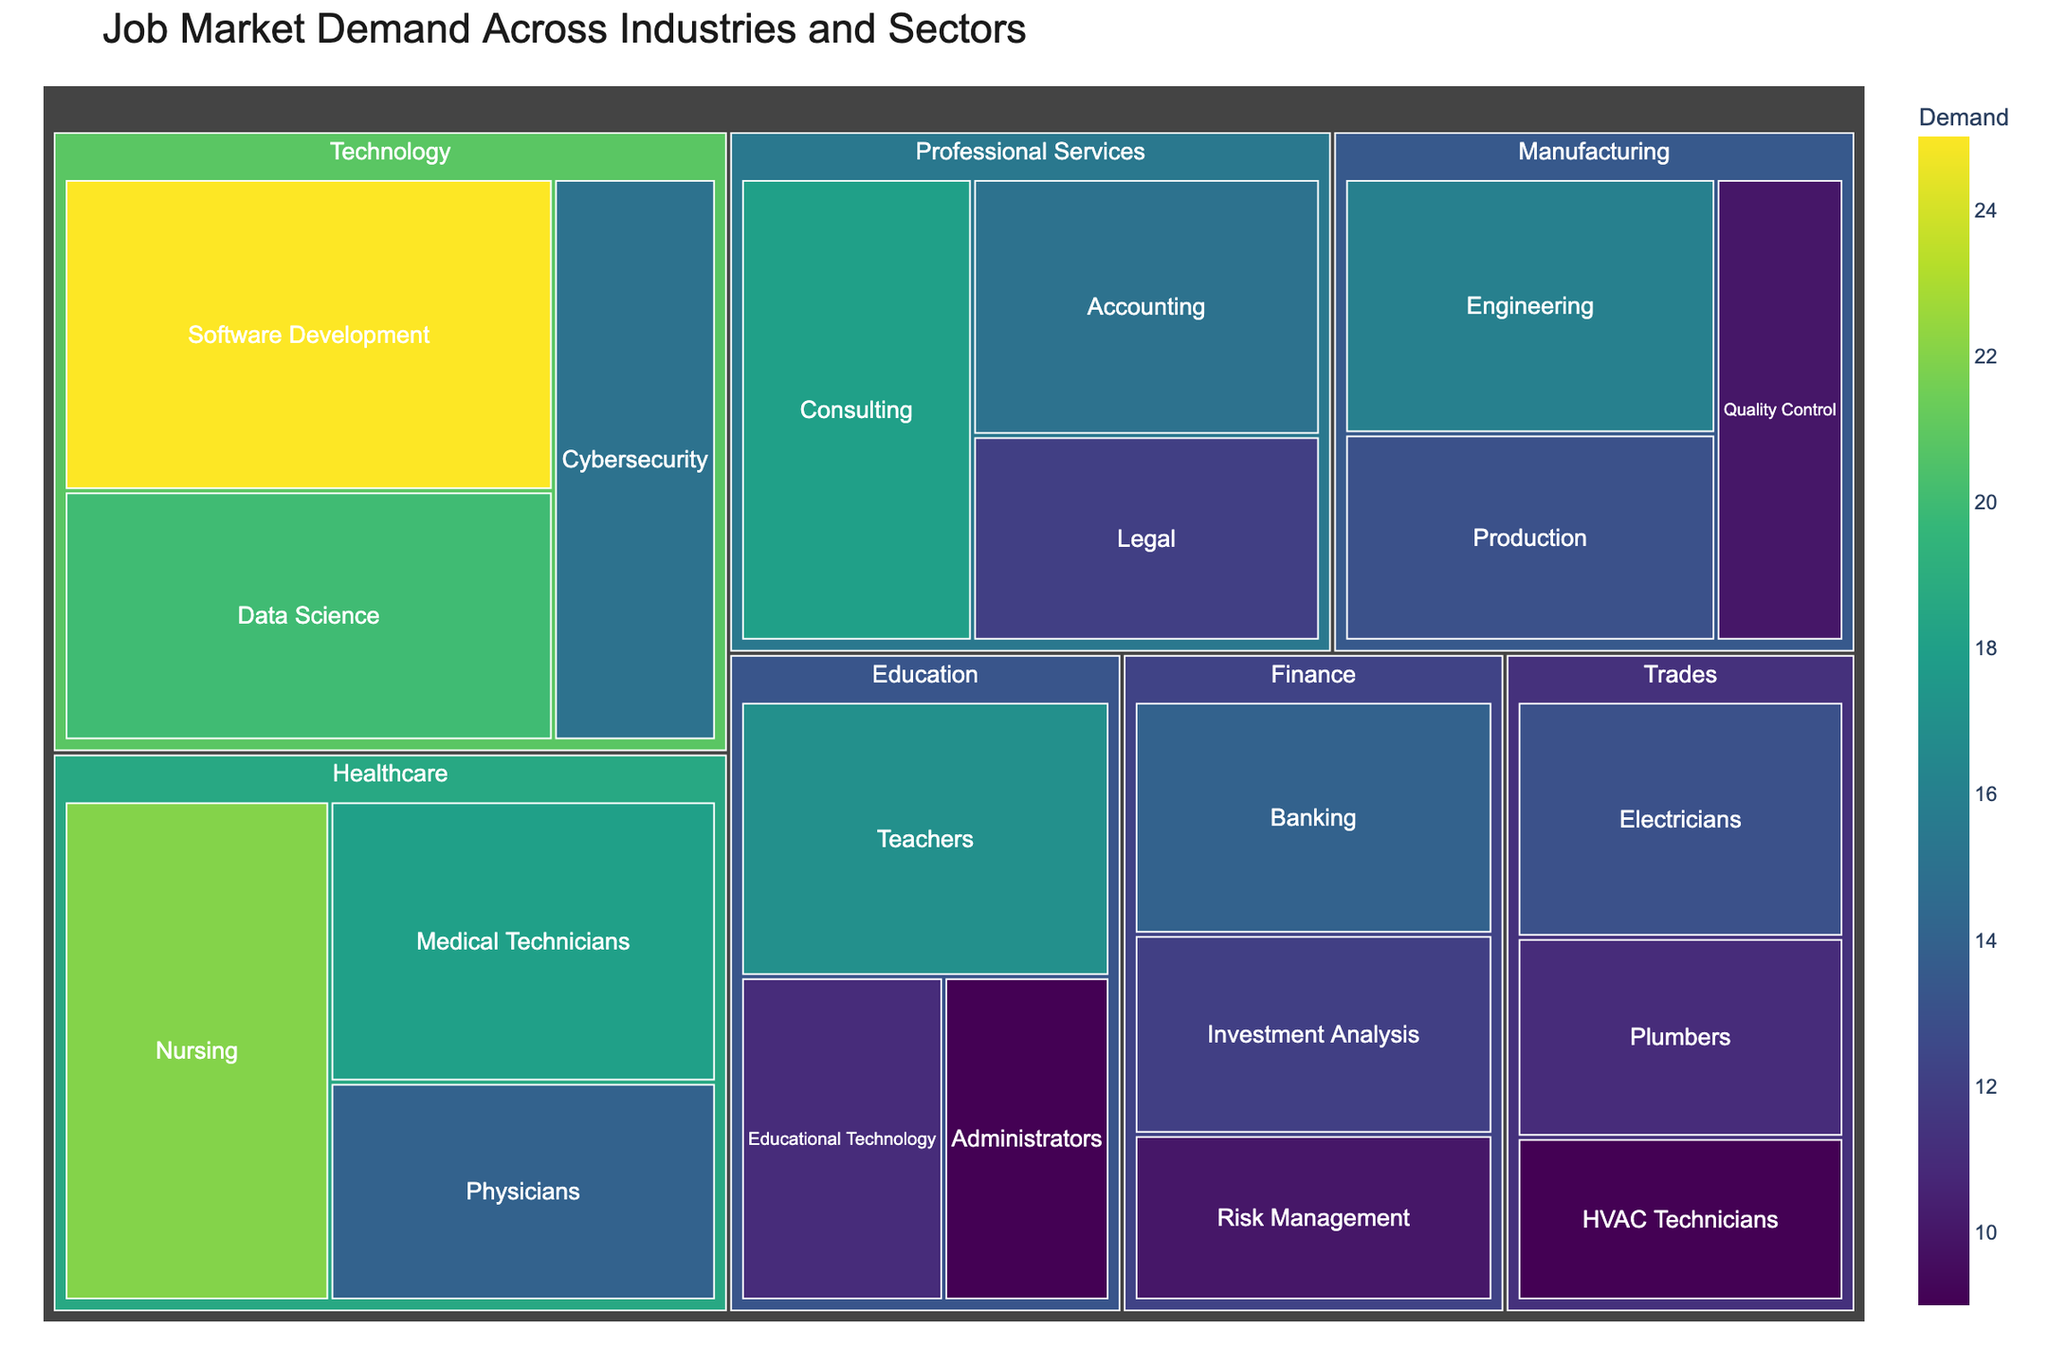what is the title of the figure? The title is usually displayed prominently at the top of a figure, in a larger font size compared to other text elements.
Answer: Job Market Demand Across Industries and Sectors what industry has the highest demand? Look for the largest rectangular area in the treemap, as size represents demand. In this case, Technology sectors have the largest combined area.
Answer: Technology what sector in Healthcare has the highest demand? Identify the blocks within Healthcare and compare them visually. Nursing has the largest area among Healthcare sectors.
Answer: Nursing how does the demand in Consulting compare to Cybersecurity? The area size represents demand. Consulting's area is larger than Cybersecurity's.
Answer: Consulting has higher demand if you combine the demands of Teachers and Nurses, what’s the total? Add the demands from the Education sector for Teachers and the Healthcare sector for Nurses. Teachers demand is 17 and Nurses are at 22. 17 + 22.
Answer: 39 what color represents the highest demand level? The treemap uses color gradients to indicate demand levels, with higher demands appearing in more intense color shades. Since Viridis is used, the highest demand color would be towards the yellow end of the spectrum.
Answer: Yellow which sector has a demand equal to that of Accounting? Find another sector whose area size and color match Accounting, which has a demand of 15. With similar inspection, Cybersecurity also has a demand of 15.
Answer: Cybersecurity what two sectors in the Manufacturing industry have a combined demand higher than Physicians? Compare individual demands in Manufacturing to identify sectors. For example, Engineering (16) and Quality Control (10) sum up to 26, greater than Physicians' 14.
Answer: Engineering and Quality Control on average, how high is the demand in Trades sectors? Sum the demands in Trades (Electricians 13, Plumbers 11, HVAC Technicians 9) and divide by the number of sectors, which is 3: (13+11+9)/3.
Answer: 11 which industry has the most sectors with demands less than 10? Identify sectors with demands less than 10 and tally them for each industry. Education and Trades have one each, which means both Education and Trades equally have the most.
Answer: Education and Trades 